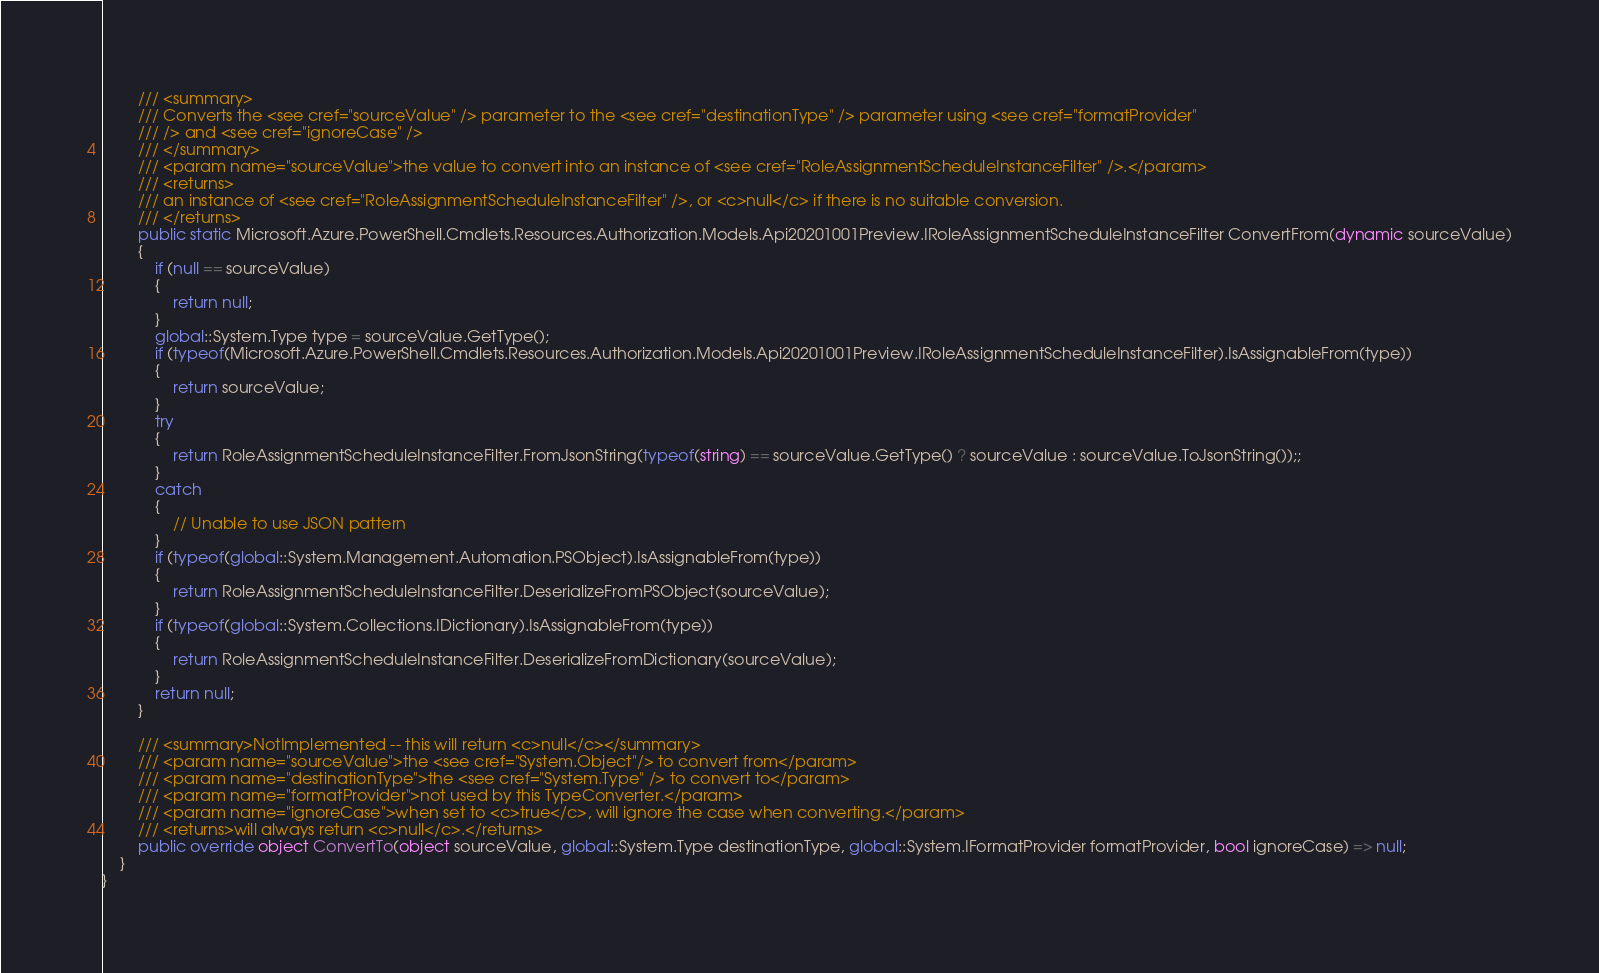Convert code to text. <code><loc_0><loc_0><loc_500><loc_500><_C#_>        /// <summary>
        /// Converts the <see cref="sourceValue" /> parameter to the <see cref="destinationType" /> parameter using <see cref="formatProvider"
        /// /> and <see cref="ignoreCase" />
        /// </summary>
        /// <param name="sourceValue">the value to convert into an instance of <see cref="RoleAssignmentScheduleInstanceFilter" />.</param>
        /// <returns>
        /// an instance of <see cref="RoleAssignmentScheduleInstanceFilter" />, or <c>null</c> if there is no suitable conversion.
        /// </returns>
        public static Microsoft.Azure.PowerShell.Cmdlets.Resources.Authorization.Models.Api20201001Preview.IRoleAssignmentScheduleInstanceFilter ConvertFrom(dynamic sourceValue)
        {
            if (null == sourceValue)
            {
                return null;
            }
            global::System.Type type = sourceValue.GetType();
            if (typeof(Microsoft.Azure.PowerShell.Cmdlets.Resources.Authorization.Models.Api20201001Preview.IRoleAssignmentScheduleInstanceFilter).IsAssignableFrom(type))
            {
                return sourceValue;
            }
            try
            {
                return RoleAssignmentScheduleInstanceFilter.FromJsonString(typeof(string) == sourceValue.GetType() ? sourceValue : sourceValue.ToJsonString());;
            }
            catch
            {
                // Unable to use JSON pattern
            }
            if (typeof(global::System.Management.Automation.PSObject).IsAssignableFrom(type))
            {
                return RoleAssignmentScheduleInstanceFilter.DeserializeFromPSObject(sourceValue);
            }
            if (typeof(global::System.Collections.IDictionary).IsAssignableFrom(type))
            {
                return RoleAssignmentScheduleInstanceFilter.DeserializeFromDictionary(sourceValue);
            }
            return null;
        }

        /// <summary>NotImplemented -- this will return <c>null</c></summary>
        /// <param name="sourceValue">the <see cref="System.Object"/> to convert from</param>
        /// <param name="destinationType">the <see cref="System.Type" /> to convert to</param>
        /// <param name="formatProvider">not used by this TypeConverter.</param>
        /// <param name="ignoreCase">when set to <c>true</c>, will ignore the case when converting.</param>
        /// <returns>will always return <c>null</c>.</returns>
        public override object ConvertTo(object sourceValue, global::System.Type destinationType, global::System.IFormatProvider formatProvider, bool ignoreCase) => null;
    }
}</code> 